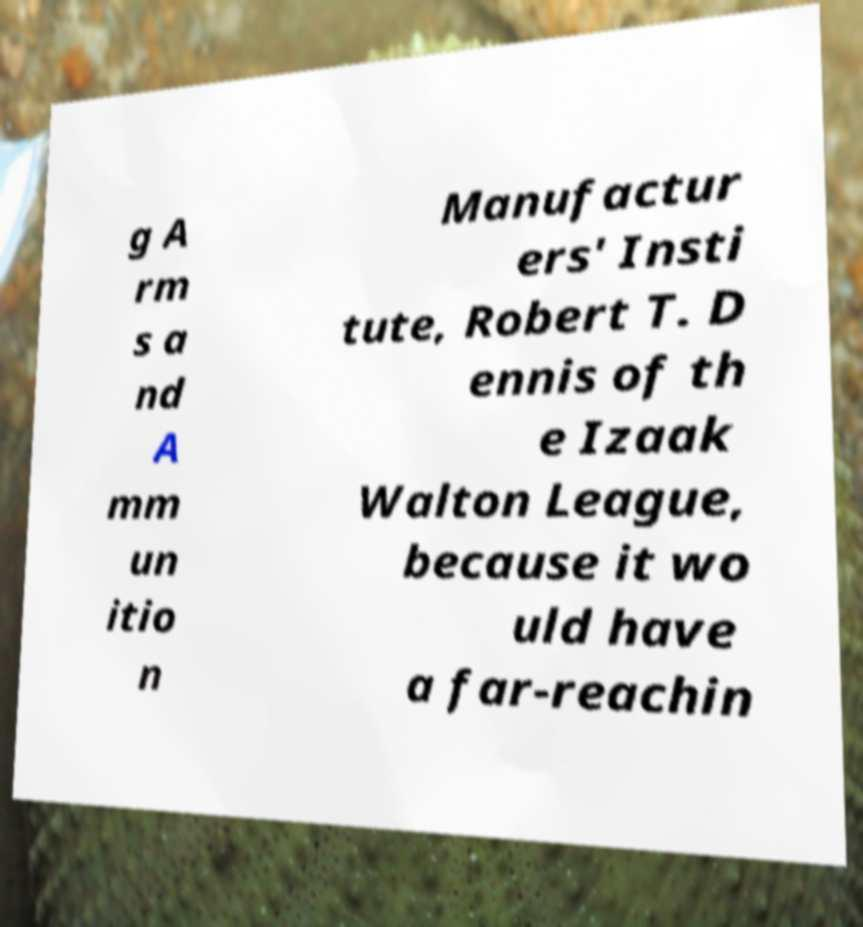Can you read and provide the text displayed in the image?This photo seems to have some interesting text. Can you extract and type it out for me? g A rm s a nd A mm un itio n Manufactur ers' Insti tute, Robert T. D ennis of th e Izaak Walton League, because it wo uld have a far-reachin 